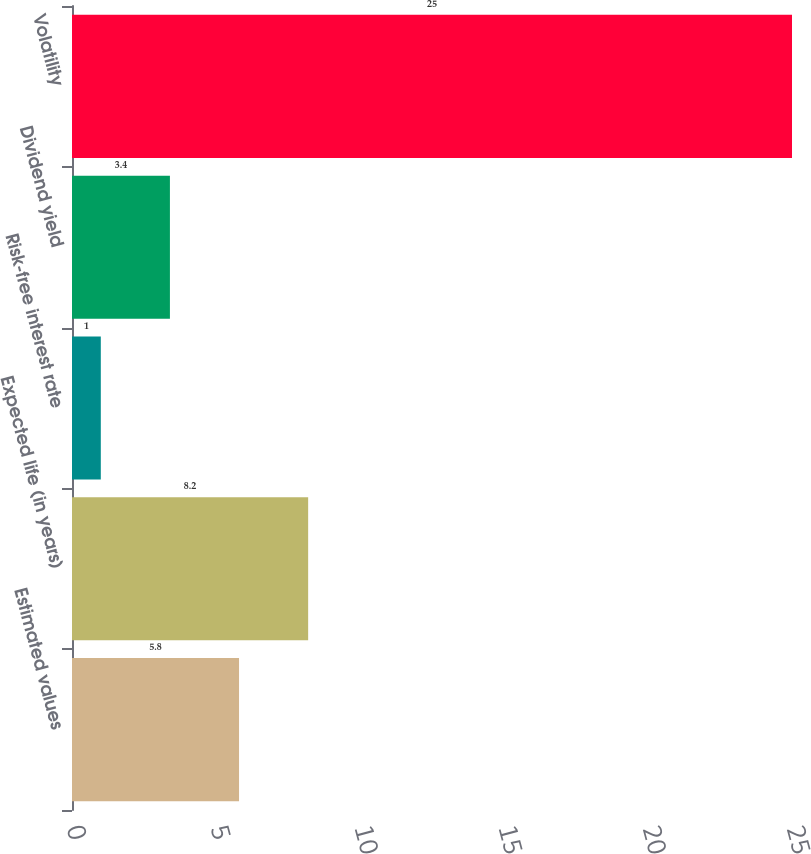Convert chart to OTSL. <chart><loc_0><loc_0><loc_500><loc_500><bar_chart><fcel>Estimated values<fcel>Expected life (in years)<fcel>Risk-free interest rate<fcel>Dividend yield<fcel>Volatility<nl><fcel>5.8<fcel>8.2<fcel>1<fcel>3.4<fcel>25<nl></chart> 